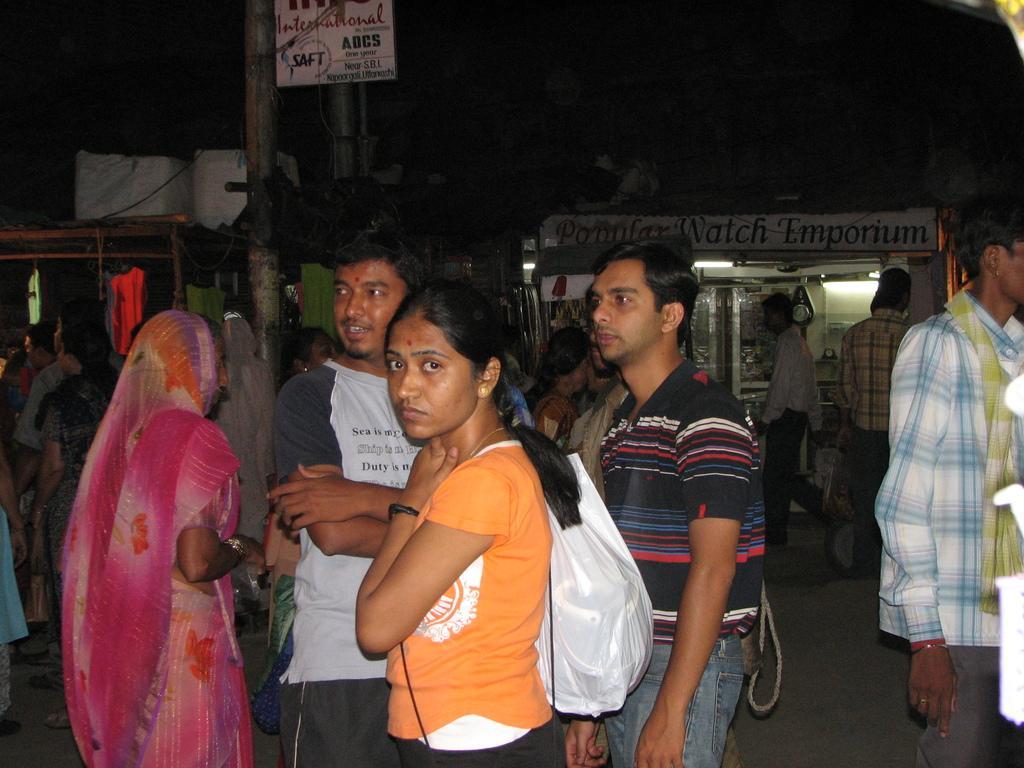Please provide a concise description of this image. This image consists of some people in the middle. One of them is holding a cover. There are shops in the middle. There is a pole in the middle. 